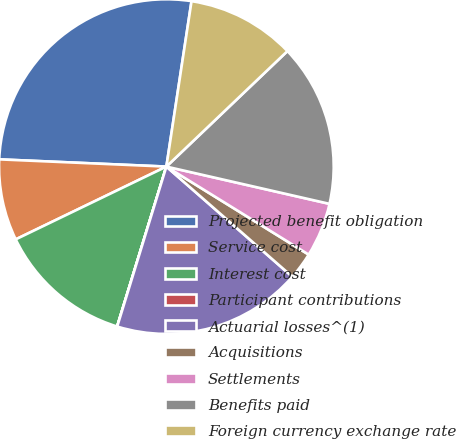<chart> <loc_0><loc_0><loc_500><loc_500><pie_chart><fcel>Projected benefit obligation<fcel>Service cost<fcel>Interest cost<fcel>Participant contributions<fcel>Actuarial losses^(1)<fcel>Acquisitions<fcel>Settlements<fcel>Benefits paid<fcel>Foreign currency exchange rate<nl><fcel>26.71%<fcel>7.85%<fcel>13.08%<fcel>0.01%<fcel>18.31%<fcel>2.62%<fcel>5.24%<fcel>15.7%<fcel>10.47%<nl></chart> 